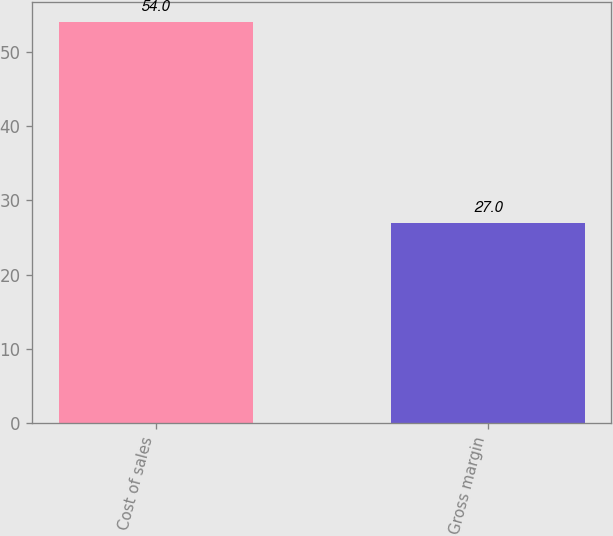<chart> <loc_0><loc_0><loc_500><loc_500><bar_chart><fcel>Cost of sales<fcel>Gross margin<nl><fcel>54<fcel>27<nl></chart> 